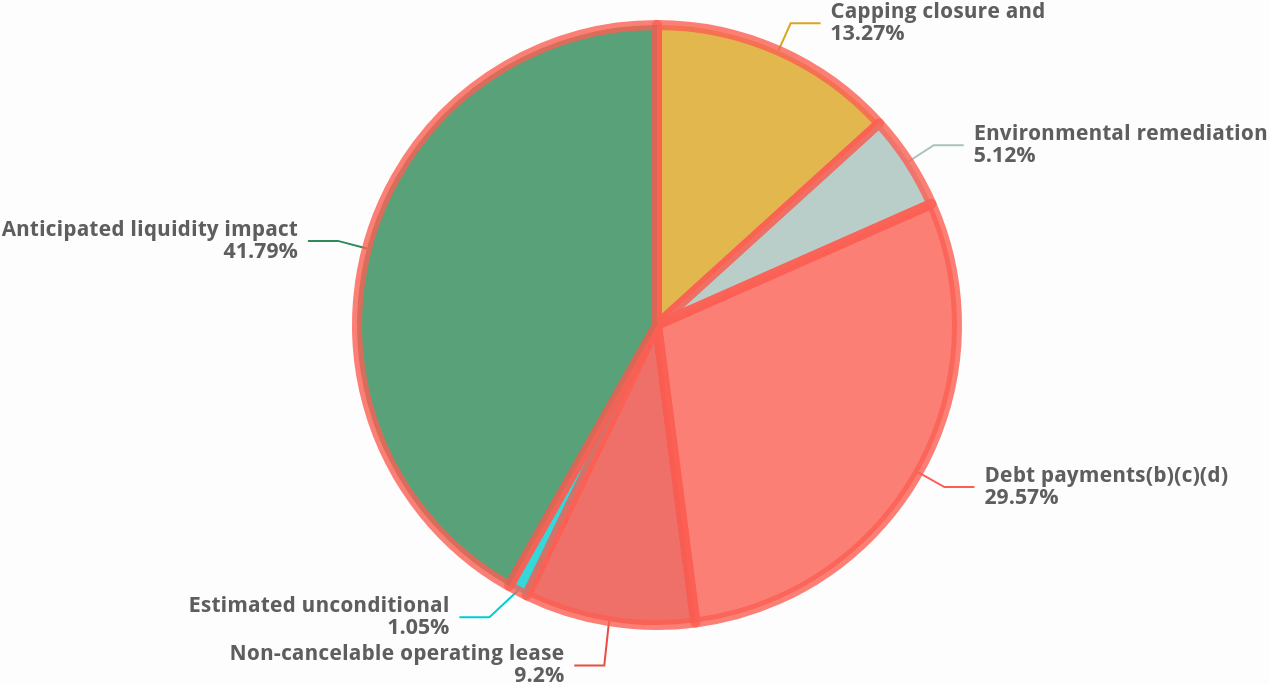<chart> <loc_0><loc_0><loc_500><loc_500><pie_chart><fcel>Capping closure and<fcel>Environmental remediation<fcel>Debt payments(b)(c)(d)<fcel>Non-cancelable operating lease<fcel>Estimated unconditional<fcel>Anticipated liquidity impact<nl><fcel>13.27%<fcel>5.12%<fcel>29.57%<fcel>9.2%<fcel>1.05%<fcel>41.8%<nl></chart> 